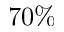Convert formula to latex. <formula><loc_0><loc_0><loc_500><loc_500>7 0 \%</formula> 